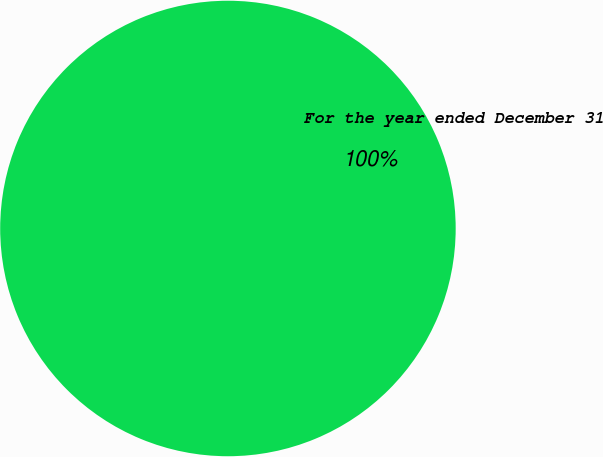<chart> <loc_0><loc_0><loc_500><loc_500><pie_chart><fcel>For the year ended December 31<nl><fcel>100.0%<nl></chart> 